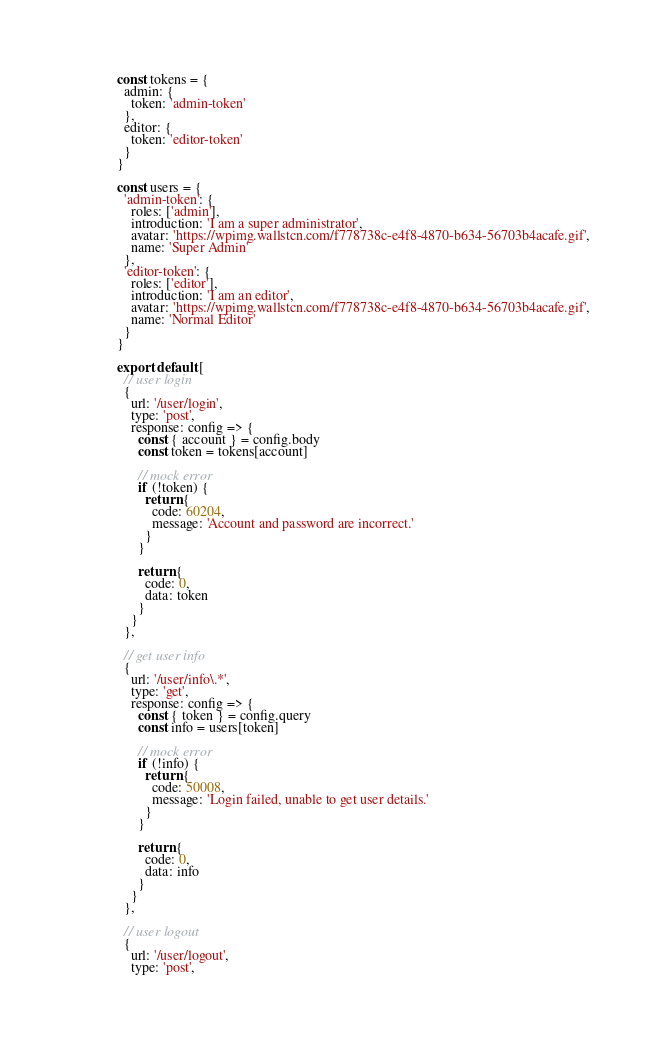<code> <loc_0><loc_0><loc_500><loc_500><_JavaScript_>
const tokens = {
  admin: {
    token: 'admin-token'
  },
  editor: {
    token: 'editor-token'
  }
}

const users = {
  'admin-token': {
    roles: ['admin'],
    introduction: 'I am a super administrator',
    avatar: 'https://wpimg.wallstcn.com/f778738c-e4f8-4870-b634-56703b4acafe.gif',
    name: 'Super Admin'
  },
  'editor-token': {
    roles: ['editor'],
    introduction: 'I am an editor',
    avatar: 'https://wpimg.wallstcn.com/f778738c-e4f8-4870-b634-56703b4acafe.gif',
    name: 'Normal Editor'
  }
}

export default [
  // user login
  {
    url: '/user/login',
    type: 'post',
    response: config => {
      const { account } = config.body
      const token = tokens[account]

      // mock error
      if (!token) {
        return {
          code: 60204,
          message: 'Account and password are incorrect.'
        }
      }

      return {
        code: 0,
        data: token
      }
    }
  },

  // get user info
  {
    url: '/user/info\.*',
    type: 'get',
    response: config => {
      const { token } = config.query
      const info = users[token]

      // mock error
      if (!info) {
        return {
          code: 50008,
          message: 'Login failed, unable to get user details.'
        }
      }

      return {
        code: 0,
        data: info
      }
    }
  },

  // user logout
  {
    url: '/user/logout',
    type: 'post',</code> 